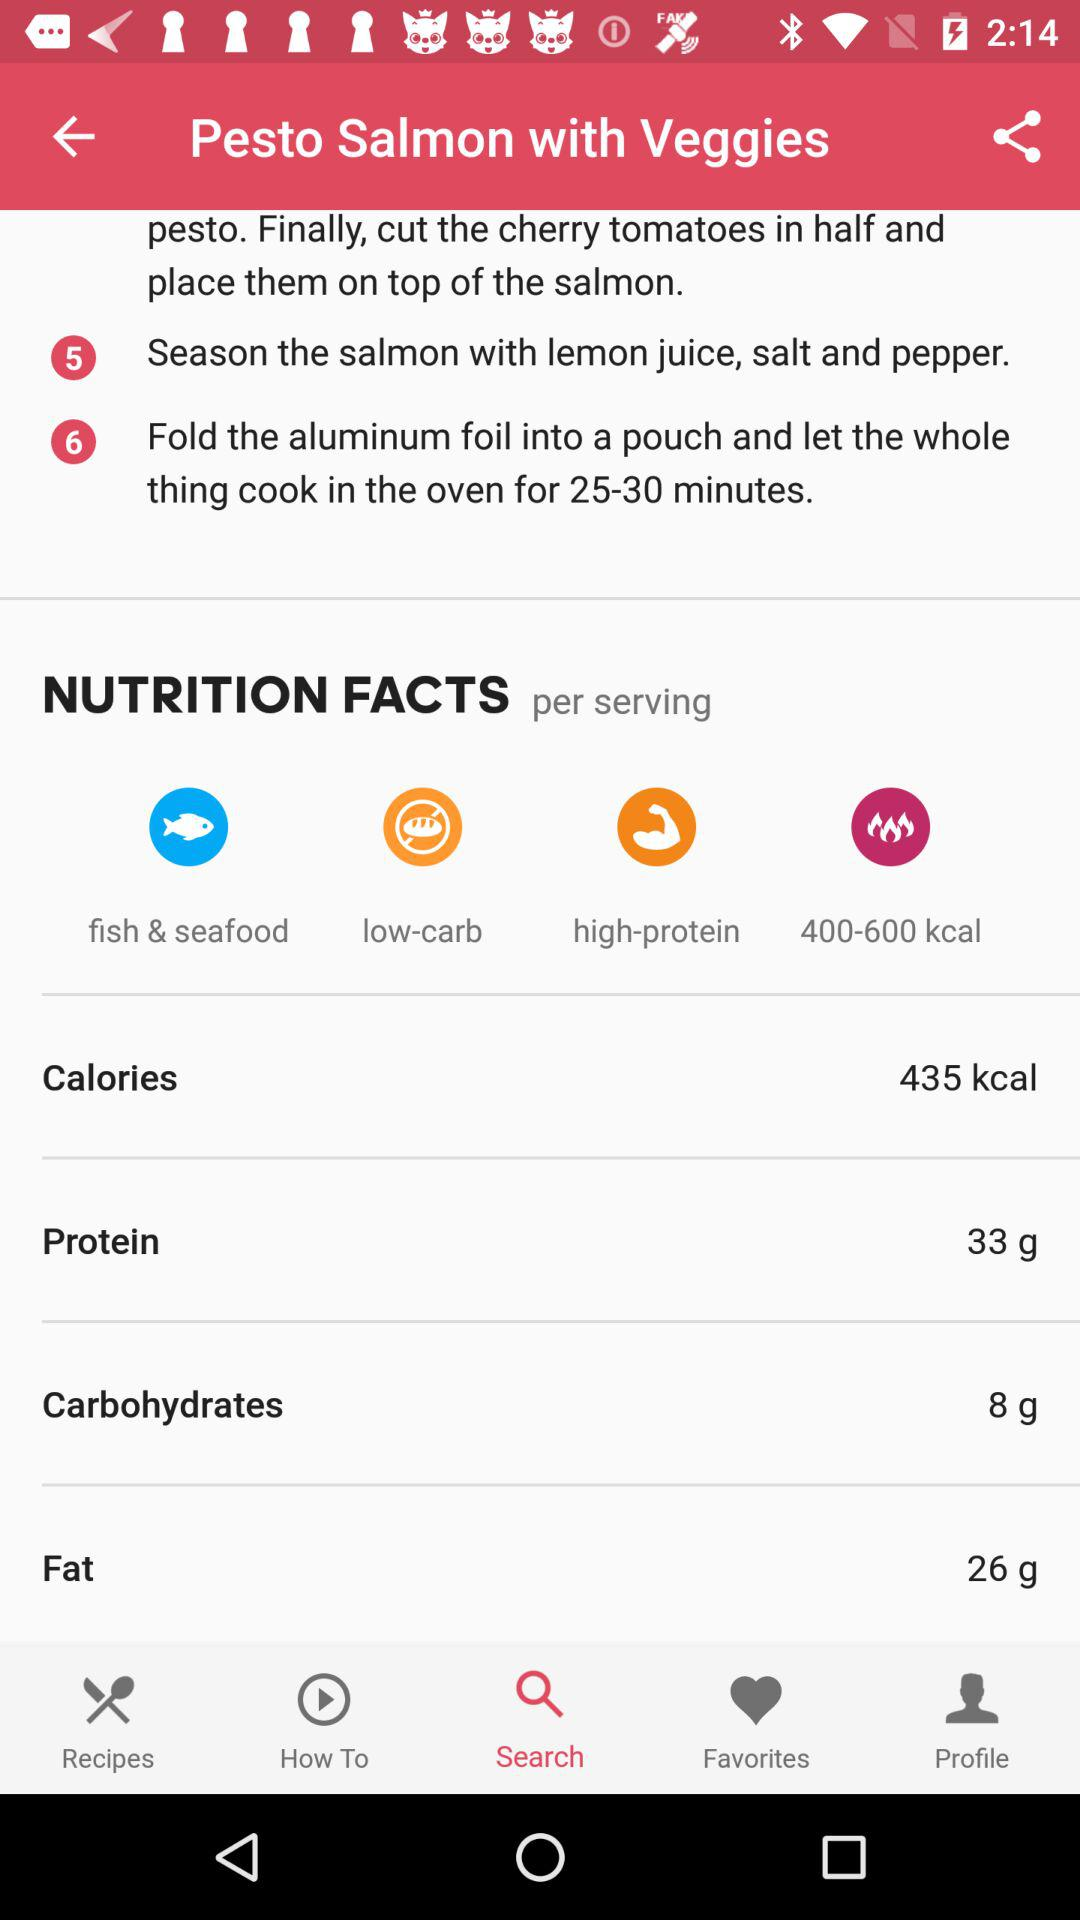How many calories are in a serving of this recipe?
Answer the question using a single word or phrase. 435 kcal 